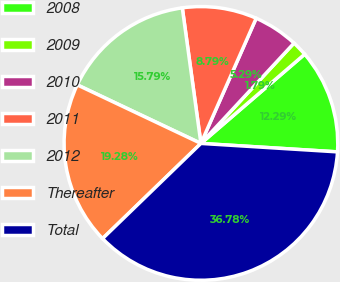Convert chart. <chart><loc_0><loc_0><loc_500><loc_500><pie_chart><fcel>2008<fcel>2009<fcel>2010<fcel>2011<fcel>2012<fcel>Thereafter<fcel>Total<nl><fcel>12.29%<fcel>1.79%<fcel>5.29%<fcel>8.79%<fcel>15.79%<fcel>19.28%<fcel>36.78%<nl></chart> 